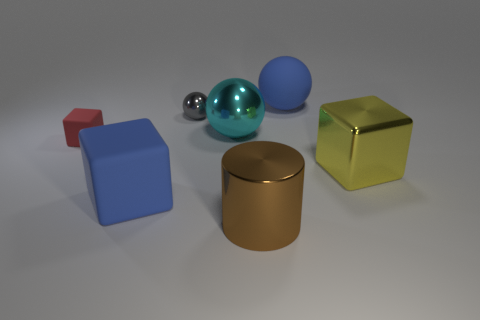How many things are big blue rubber objects behind the large cyan thing or big blue rubber things in front of the rubber ball?
Your answer should be very brief. 2. There is a metallic cylinder in front of the tiny ball; does it have the same color as the big matte sphere?
Make the answer very short. No. How many other things are the same color as the large matte ball?
Offer a very short reply. 1. What is the tiny cube made of?
Make the answer very short. Rubber. Does the red rubber thing left of the yellow shiny block have the same size as the big brown object?
Your answer should be compact. No. Is there any other thing that has the same size as the gray metal ball?
Offer a terse response. Yes. What size is the other rubber thing that is the same shape as the cyan thing?
Make the answer very short. Large. Are there the same number of metallic things right of the large yellow shiny object and yellow objects that are left of the tiny metallic thing?
Offer a terse response. Yes. What size is the blue object that is on the right side of the big cylinder?
Provide a succinct answer. Large. Does the big rubber sphere have the same color as the metal cube?
Ensure brevity in your answer.  No. 